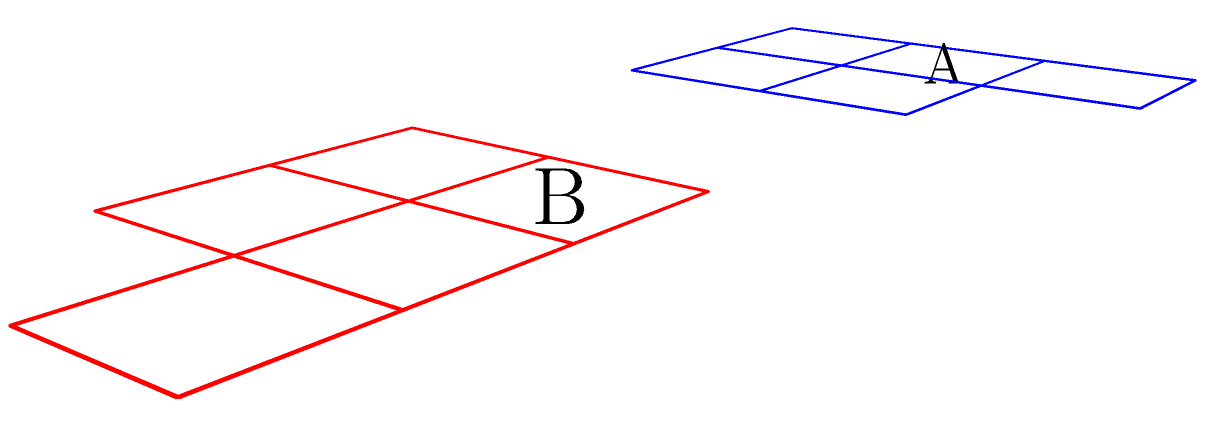Which of the unfolded nets (A or B) represents the correct pattern for assembling a traditional Maori carving in the shape of a rectangular prism with dimensions 2x2x3 units? To determine the correct unfolded net for a traditional Maori carving in the shape of a rectangular prism with dimensions 2x2x3 units, we need to analyze both nets:

1. First, let's count the number of faces:
   - A rectangular prism with dimensions 2x2x3 should have 6 faces in total.
   - Both nets A and B have 5 faces, which is correct as the bottom face is usually omitted in an unfolded net.

2. Now, let's examine the dimensions:
   - The prism should have two 2x2 faces, two 2x3 faces, and two 3x2 faces.
   - In both nets, we can see four 2x2 squares, which could form the four sides of the prism.
   - The difference lies in the position of the fifth face, which should be 2x3 to form the top of the prism.

3. Analyzing Net A:
   - The fifth face (top piece) is correctly positioned to fold into a 2x3 top face.
   - When folded, this net would create a 2x2x3 rectangular prism.

4. Analyzing Net B:
   - The fifth face is positioned on the side, which would result in a 2x2x2 cube when folded.
   - This does not match the required 2x2x3 dimensions.

5. Cultural context:
   - Traditional Maori carvings often have elongated forms, which aligns better with the 2x2x3 prism shape represented by Net A.

Therefore, Net A is the correct unfolded net for assembling a traditional Maori carving in the shape of a 2x2x3 rectangular prism.
Answer: A 